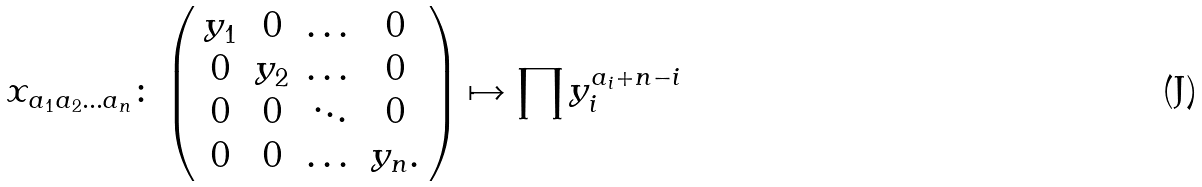<formula> <loc_0><loc_0><loc_500><loc_500>x _ { a _ { 1 } a _ { 2 } \dots a _ { n } } \colon \left ( \begin{array} { c c c c } y _ { 1 } & 0 & \dots & 0 \\ 0 & y _ { 2 } & \dots & 0 \\ 0 & 0 & \ddots & 0 \\ 0 & 0 & \dots & y _ { n } . \end{array} \right ) \mapsto \prod y _ { i } ^ { a _ { i } + n - i }</formula> 